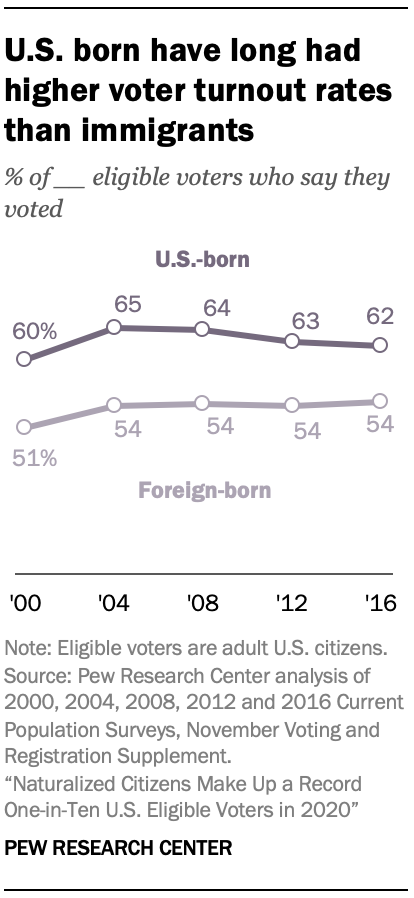Mention a couple of crucial points in this snapshot. The median value of U.S.-born graphs is 63. In 2016, approximately 62% of eligible voters in the United States were born in the United States. 